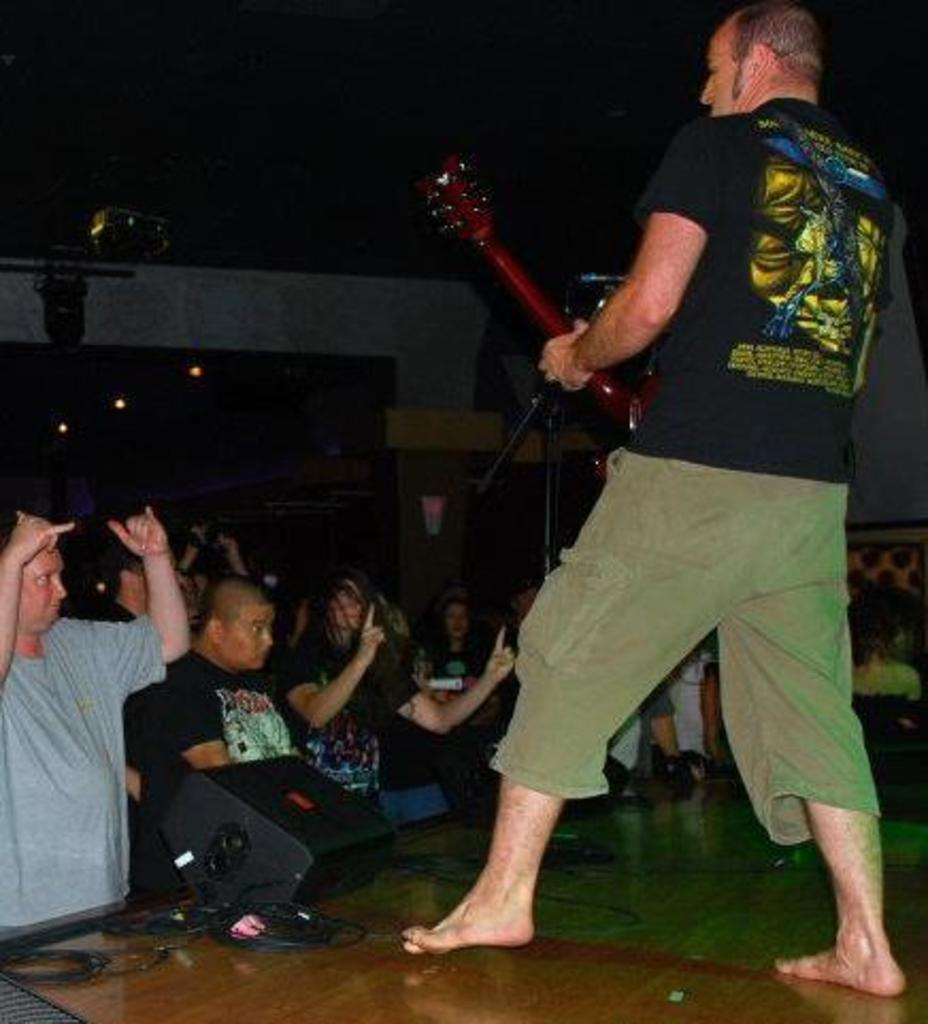What is the person in the image doing? The person is playing a guitar. What is the person wearing in the image? The person is wearing a black shirt. What object is in front of the person? There is a microphone in front of the person. Who is present in front of the person? There are audience members in front of the person. What type of veil is the person wearing over their arm in the image? There is no veil present in the image, nor is there any indication that the person's arm is covered. 